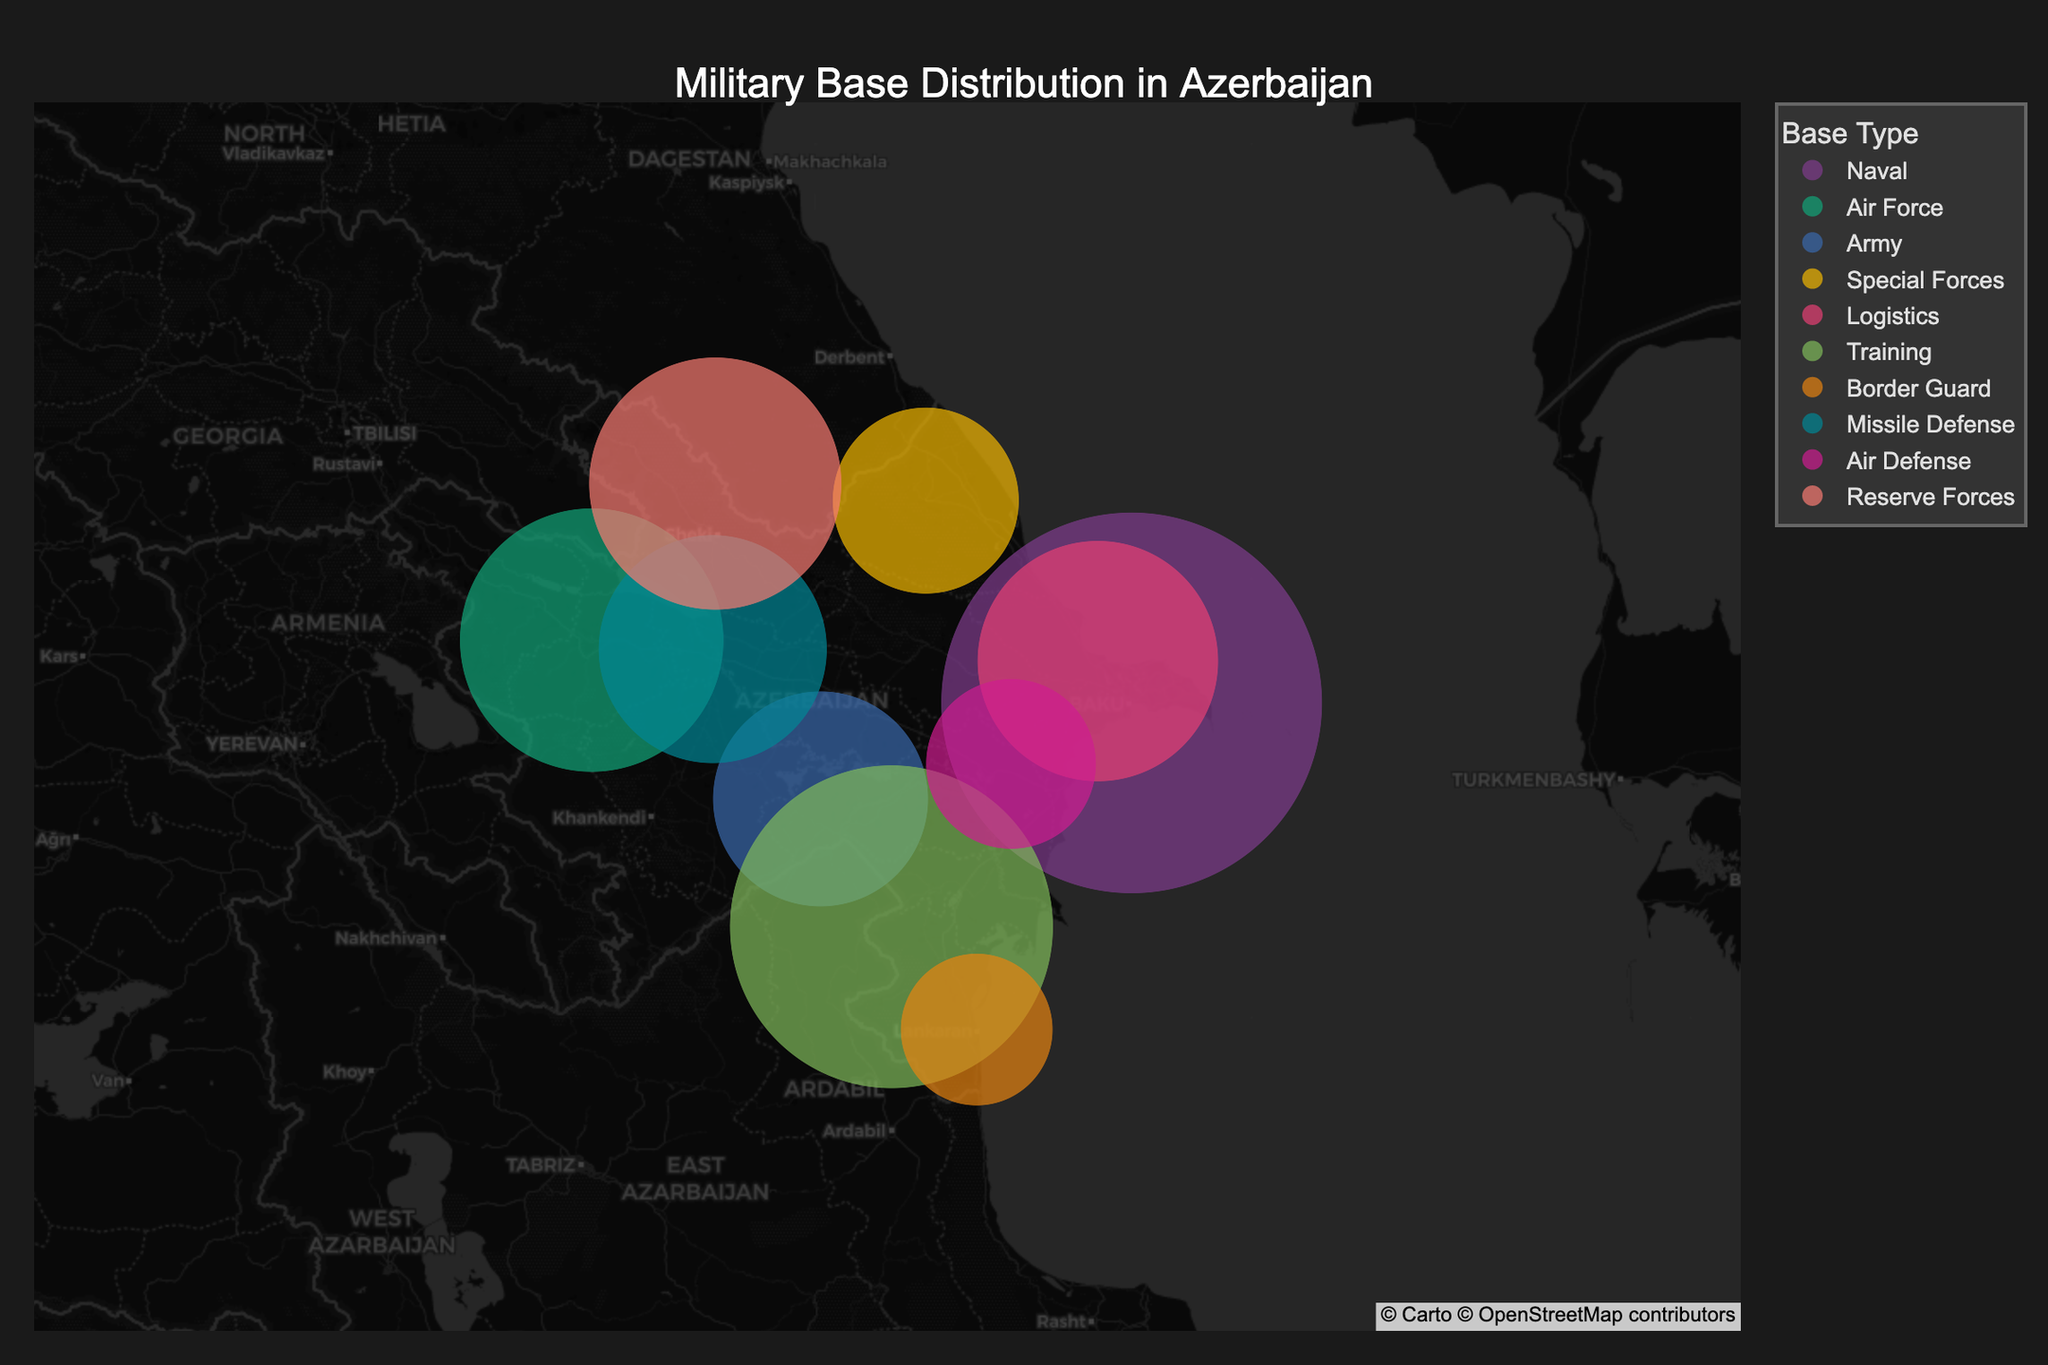How many different types of military bases are displayed on the map? The legend of the map shows different base types indicated by unique colors.
Answer: 8 Which military base has the largest personnel? Looking at the size of the dots, the largest one represents the Baku Naval Base with 2500 personnel.
Answer: Baku Naval Base Where are the two Air Force bases located? By referring to the legend and looking at the corresponding colors, Ganja Air Base and Shirvan Air Defense Base are located in Ganja and Shirvan respectively.
Answer: Ganja and Shirvan What is the total number of personnel in all medium-sized bases? Adding the personnel from Ganja Air Base (1200), Sumgayit Logistics Center (1000), Mingachevir Missile Defense (900), and Sheki Reserve Forces Camp (1100). The total is 1200 + 1000 + 900 + 1100 = 4200.
Answer: 4200 Which base type has the smallest total personnel? Summing the personnel in Special Forces (Quba Special Forces Base: 600), Border Guard (Jalilabad Border Guard Post: 400), and Air Defense (Shirvan Air Defense Base: 500), Special Forces has the smallest total with 600 personnel.
Answer: Special Forces Compare the number of personnel in the Baku Naval Base to the combined personnel of all Special Forces bases. The Baku Naval Base has 2500 personnel. There is one Special Forces base (Quba Special Forces Base) with 600 personnel. Therefore, 2500 is greater than 600.
Answer: Baku Naval Base has more personnel What's the average size of personnel in small-sized bases? Summing the personnel in small bases (Yevlakh Army Base: 800, Quba Special Forces Base: 600, Jalilabad Border Guard Post: 400, and Shirvan Air Defense Base: 500) and dividing by the number of bases (4): (800 + 600 + 400 + 500) / 4 = 575.
Answer: 575 Calculate the ratio of personnel between the largest and smallest base. The largest base, Baku Naval Base, has 2500 personnel, and the smallest, Jalilabad Border Guard Post, has 400. The ratio is 2500/400 = 6.25.
Answer: 6.25 What type of base is located furthest north? By checking the map, the northernmost base is Quba Special Forces Base, identified by the position on the map.
Answer: Special Forces 